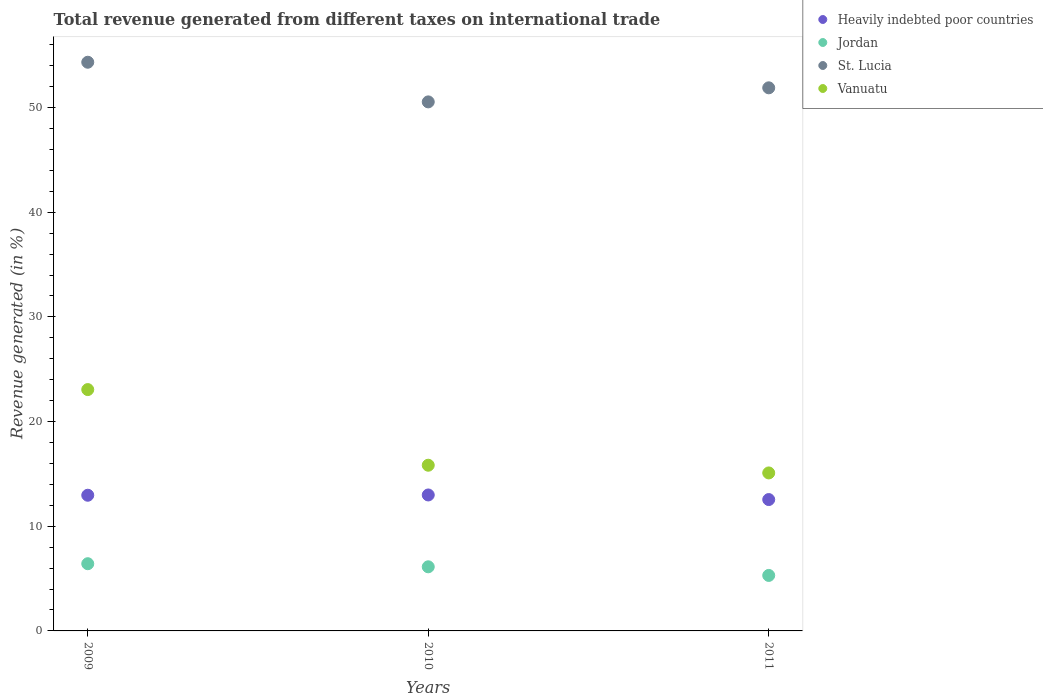Is the number of dotlines equal to the number of legend labels?
Provide a short and direct response. Yes. What is the total revenue generated in Vanuatu in 2009?
Provide a short and direct response. 23.06. Across all years, what is the maximum total revenue generated in St. Lucia?
Offer a very short reply. 54.33. Across all years, what is the minimum total revenue generated in Vanuatu?
Keep it short and to the point. 15.09. In which year was the total revenue generated in St. Lucia maximum?
Offer a terse response. 2009. In which year was the total revenue generated in Heavily indebted poor countries minimum?
Provide a short and direct response. 2011. What is the total total revenue generated in St. Lucia in the graph?
Keep it short and to the point. 156.76. What is the difference between the total revenue generated in Jordan in 2009 and that in 2011?
Your response must be concise. 1.12. What is the difference between the total revenue generated in Heavily indebted poor countries in 2011 and the total revenue generated in St. Lucia in 2010?
Keep it short and to the point. -37.99. What is the average total revenue generated in Jordan per year?
Your response must be concise. 5.95. In the year 2011, what is the difference between the total revenue generated in Heavily indebted poor countries and total revenue generated in Vanuatu?
Provide a succinct answer. -2.54. In how many years, is the total revenue generated in Heavily indebted poor countries greater than 40 %?
Provide a succinct answer. 0. What is the ratio of the total revenue generated in Jordan in 2010 to that in 2011?
Keep it short and to the point. 1.16. Is the total revenue generated in Heavily indebted poor countries in 2010 less than that in 2011?
Your answer should be compact. No. Is the difference between the total revenue generated in Heavily indebted poor countries in 2010 and 2011 greater than the difference between the total revenue generated in Vanuatu in 2010 and 2011?
Provide a succinct answer. No. What is the difference between the highest and the second highest total revenue generated in Vanuatu?
Ensure brevity in your answer.  7.23. What is the difference between the highest and the lowest total revenue generated in Jordan?
Provide a short and direct response. 1.12. Is the sum of the total revenue generated in Heavily indebted poor countries in 2010 and 2011 greater than the maximum total revenue generated in St. Lucia across all years?
Ensure brevity in your answer.  No. Does the total revenue generated in Jordan monotonically increase over the years?
Ensure brevity in your answer.  No. Is the total revenue generated in Vanuatu strictly less than the total revenue generated in St. Lucia over the years?
Provide a succinct answer. Yes. How many years are there in the graph?
Make the answer very short. 3. Are the values on the major ticks of Y-axis written in scientific E-notation?
Offer a very short reply. No. What is the title of the graph?
Give a very brief answer. Total revenue generated from different taxes on international trade. What is the label or title of the Y-axis?
Your answer should be very brief. Revenue generated (in %). What is the Revenue generated (in %) of Heavily indebted poor countries in 2009?
Make the answer very short. 12.96. What is the Revenue generated (in %) in Jordan in 2009?
Make the answer very short. 6.42. What is the Revenue generated (in %) in St. Lucia in 2009?
Keep it short and to the point. 54.33. What is the Revenue generated (in %) in Vanuatu in 2009?
Give a very brief answer. 23.06. What is the Revenue generated (in %) in Heavily indebted poor countries in 2010?
Keep it short and to the point. 12.99. What is the Revenue generated (in %) of Jordan in 2010?
Provide a short and direct response. 6.13. What is the Revenue generated (in %) in St. Lucia in 2010?
Your response must be concise. 50.54. What is the Revenue generated (in %) in Vanuatu in 2010?
Make the answer very short. 15.83. What is the Revenue generated (in %) of Heavily indebted poor countries in 2011?
Offer a terse response. 12.55. What is the Revenue generated (in %) of Jordan in 2011?
Ensure brevity in your answer.  5.3. What is the Revenue generated (in %) in St. Lucia in 2011?
Ensure brevity in your answer.  51.89. What is the Revenue generated (in %) of Vanuatu in 2011?
Your answer should be very brief. 15.09. Across all years, what is the maximum Revenue generated (in %) of Heavily indebted poor countries?
Your answer should be very brief. 12.99. Across all years, what is the maximum Revenue generated (in %) in Jordan?
Offer a terse response. 6.42. Across all years, what is the maximum Revenue generated (in %) in St. Lucia?
Ensure brevity in your answer.  54.33. Across all years, what is the maximum Revenue generated (in %) of Vanuatu?
Ensure brevity in your answer.  23.06. Across all years, what is the minimum Revenue generated (in %) in Heavily indebted poor countries?
Make the answer very short. 12.55. Across all years, what is the minimum Revenue generated (in %) in Jordan?
Give a very brief answer. 5.3. Across all years, what is the minimum Revenue generated (in %) of St. Lucia?
Offer a terse response. 50.54. Across all years, what is the minimum Revenue generated (in %) of Vanuatu?
Your response must be concise. 15.09. What is the total Revenue generated (in %) of Heavily indebted poor countries in the graph?
Your answer should be very brief. 38.5. What is the total Revenue generated (in %) in Jordan in the graph?
Keep it short and to the point. 17.85. What is the total Revenue generated (in %) of St. Lucia in the graph?
Your response must be concise. 156.76. What is the total Revenue generated (in %) of Vanuatu in the graph?
Make the answer very short. 53.98. What is the difference between the Revenue generated (in %) in Heavily indebted poor countries in 2009 and that in 2010?
Keep it short and to the point. -0.03. What is the difference between the Revenue generated (in %) in Jordan in 2009 and that in 2010?
Keep it short and to the point. 0.3. What is the difference between the Revenue generated (in %) of St. Lucia in 2009 and that in 2010?
Your answer should be very brief. 3.79. What is the difference between the Revenue generated (in %) in Vanuatu in 2009 and that in 2010?
Provide a succinct answer. 7.23. What is the difference between the Revenue generated (in %) in Heavily indebted poor countries in 2009 and that in 2011?
Keep it short and to the point. 0.41. What is the difference between the Revenue generated (in %) in Jordan in 2009 and that in 2011?
Keep it short and to the point. 1.12. What is the difference between the Revenue generated (in %) of St. Lucia in 2009 and that in 2011?
Provide a short and direct response. 2.44. What is the difference between the Revenue generated (in %) of Vanuatu in 2009 and that in 2011?
Your answer should be compact. 7.96. What is the difference between the Revenue generated (in %) in Heavily indebted poor countries in 2010 and that in 2011?
Provide a short and direct response. 0.44. What is the difference between the Revenue generated (in %) of Jordan in 2010 and that in 2011?
Your answer should be compact. 0.82. What is the difference between the Revenue generated (in %) of St. Lucia in 2010 and that in 2011?
Offer a terse response. -1.34. What is the difference between the Revenue generated (in %) of Vanuatu in 2010 and that in 2011?
Your response must be concise. 0.74. What is the difference between the Revenue generated (in %) in Heavily indebted poor countries in 2009 and the Revenue generated (in %) in Jordan in 2010?
Offer a very short reply. 6.84. What is the difference between the Revenue generated (in %) of Heavily indebted poor countries in 2009 and the Revenue generated (in %) of St. Lucia in 2010?
Make the answer very short. -37.58. What is the difference between the Revenue generated (in %) in Heavily indebted poor countries in 2009 and the Revenue generated (in %) in Vanuatu in 2010?
Your answer should be compact. -2.87. What is the difference between the Revenue generated (in %) in Jordan in 2009 and the Revenue generated (in %) in St. Lucia in 2010?
Your answer should be compact. -44.12. What is the difference between the Revenue generated (in %) of Jordan in 2009 and the Revenue generated (in %) of Vanuatu in 2010?
Offer a terse response. -9.41. What is the difference between the Revenue generated (in %) in St. Lucia in 2009 and the Revenue generated (in %) in Vanuatu in 2010?
Provide a succinct answer. 38.5. What is the difference between the Revenue generated (in %) of Heavily indebted poor countries in 2009 and the Revenue generated (in %) of Jordan in 2011?
Provide a succinct answer. 7.66. What is the difference between the Revenue generated (in %) in Heavily indebted poor countries in 2009 and the Revenue generated (in %) in St. Lucia in 2011?
Your answer should be compact. -38.92. What is the difference between the Revenue generated (in %) in Heavily indebted poor countries in 2009 and the Revenue generated (in %) in Vanuatu in 2011?
Your response must be concise. -2.13. What is the difference between the Revenue generated (in %) of Jordan in 2009 and the Revenue generated (in %) of St. Lucia in 2011?
Your response must be concise. -45.46. What is the difference between the Revenue generated (in %) in Jordan in 2009 and the Revenue generated (in %) in Vanuatu in 2011?
Your answer should be compact. -8.67. What is the difference between the Revenue generated (in %) of St. Lucia in 2009 and the Revenue generated (in %) of Vanuatu in 2011?
Ensure brevity in your answer.  39.24. What is the difference between the Revenue generated (in %) of Heavily indebted poor countries in 2010 and the Revenue generated (in %) of Jordan in 2011?
Your answer should be very brief. 7.69. What is the difference between the Revenue generated (in %) in Heavily indebted poor countries in 2010 and the Revenue generated (in %) in St. Lucia in 2011?
Offer a very short reply. -38.9. What is the difference between the Revenue generated (in %) of Heavily indebted poor countries in 2010 and the Revenue generated (in %) of Vanuatu in 2011?
Your response must be concise. -2.11. What is the difference between the Revenue generated (in %) in Jordan in 2010 and the Revenue generated (in %) in St. Lucia in 2011?
Your answer should be very brief. -45.76. What is the difference between the Revenue generated (in %) in Jordan in 2010 and the Revenue generated (in %) in Vanuatu in 2011?
Keep it short and to the point. -8.97. What is the difference between the Revenue generated (in %) of St. Lucia in 2010 and the Revenue generated (in %) of Vanuatu in 2011?
Your response must be concise. 35.45. What is the average Revenue generated (in %) in Heavily indebted poor countries per year?
Your answer should be very brief. 12.83. What is the average Revenue generated (in %) in Jordan per year?
Your answer should be compact. 5.95. What is the average Revenue generated (in %) of St. Lucia per year?
Your answer should be compact. 52.25. What is the average Revenue generated (in %) of Vanuatu per year?
Your answer should be very brief. 17.99. In the year 2009, what is the difference between the Revenue generated (in %) in Heavily indebted poor countries and Revenue generated (in %) in Jordan?
Provide a short and direct response. 6.54. In the year 2009, what is the difference between the Revenue generated (in %) of Heavily indebted poor countries and Revenue generated (in %) of St. Lucia?
Make the answer very short. -41.37. In the year 2009, what is the difference between the Revenue generated (in %) of Heavily indebted poor countries and Revenue generated (in %) of Vanuatu?
Offer a very short reply. -10.09. In the year 2009, what is the difference between the Revenue generated (in %) of Jordan and Revenue generated (in %) of St. Lucia?
Make the answer very short. -47.91. In the year 2009, what is the difference between the Revenue generated (in %) of Jordan and Revenue generated (in %) of Vanuatu?
Give a very brief answer. -16.64. In the year 2009, what is the difference between the Revenue generated (in %) in St. Lucia and Revenue generated (in %) in Vanuatu?
Your answer should be compact. 31.27. In the year 2010, what is the difference between the Revenue generated (in %) in Heavily indebted poor countries and Revenue generated (in %) in Jordan?
Offer a terse response. 6.86. In the year 2010, what is the difference between the Revenue generated (in %) of Heavily indebted poor countries and Revenue generated (in %) of St. Lucia?
Give a very brief answer. -37.55. In the year 2010, what is the difference between the Revenue generated (in %) of Heavily indebted poor countries and Revenue generated (in %) of Vanuatu?
Your answer should be compact. -2.84. In the year 2010, what is the difference between the Revenue generated (in %) of Jordan and Revenue generated (in %) of St. Lucia?
Your response must be concise. -44.42. In the year 2010, what is the difference between the Revenue generated (in %) of Jordan and Revenue generated (in %) of Vanuatu?
Your answer should be compact. -9.7. In the year 2010, what is the difference between the Revenue generated (in %) of St. Lucia and Revenue generated (in %) of Vanuatu?
Ensure brevity in your answer.  34.71. In the year 2011, what is the difference between the Revenue generated (in %) in Heavily indebted poor countries and Revenue generated (in %) in Jordan?
Give a very brief answer. 7.25. In the year 2011, what is the difference between the Revenue generated (in %) of Heavily indebted poor countries and Revenue generated (in %) of St. Lucia?
Make the answer very short. -39.34. In the year 2011, what is the difference between the Revenue generated (in %) of Heavily indebted poor countries and Revenue generated (in %) of Vanuatu?
Ensure brevity in your answer.  -2.54. In the year 2011, what is the difference between the Revenue generated (in %) of Jordan and Revenue generated (in %) of St. Lucia?
Provide a succinct answer. -46.58. In the year 2011, what is the difference between the Revenue generated (in %) of Jordan and Revenue generated (in %) of Vanuatu?
Offer a very short reply. -9.79. In the year 2011, what is the difference between the Revenue generated (in %) of St. Lucia and Revenue generated (in %) of Vanuatu?
Offer a very short reply. 36.79. What is the ratio of the Revenue generated (in %) of Heavily indebted poor countries in 2009 to that in 2010?
Offer a very short reply. 1. What is the ratio of the Revenue generated (in %) of Jordan in 2009 to that in 2010?
Provide a short and direct response. 1.05. What is the ratio of the Revenue generated (in %) of St. Lucia in 2009 to that in 2010?
Your response must be concise. 1.07. What is the ratio of the Revenue generated (in %) of Vanuatu in 2009 to that in 2010?
Offer a terse response. 1.46. What is the ratio of the Revenue generated (in %) of Heavily indebted poor countries in 2009 to that in 2011?
Make the answer very short. 1.03. What is the ratio of the Revenue generated (in %) of Jordan in 2009 to that in 2011?
Offer a very short reply. 1.21. What is the ratio of the Revenue generated (in %) of St. Lucia in 2009 to that in 2011?
Make the answer very short. 1.05. What is the ratio of the Revenue generated (in %) in Vanuatu in 2009 to that in 2011?
Make the answer very short. 1.53. What is the ratio of the Revenue generated (in %) in Heavily indebted poor countries in 2010 to that in 2011?
Make the answer very short. 1.03. What is the ratio of the Revenue generated (in %) in Jordan in 2010 to that in 2011?
Your answer should be very brief. 1.16. What is the ratio of the Revenue generated (in %) in St. Lucia in 2010 to that in 2011?
Keep it short and to the point. 0.97. What is the ratio of the Revenue generated (in %) of Vanuatu in 2010 to that in 2011?
Your answer should be compact. 1.05. What is the difference between the highest and the second highest Revenue generated (in %) of Heavily indebted poor countries?
Offer a very short reply. 0.03. What is the difference between the highest and the second highest Revenue generated (in %) of Jordan?
Give a very brief answer. 0.3. What is the difference between the highest and the second highest Revenue generated (in %) of St. Lucia?
Offer a very short reply. 2.44. What is the difference between the highest and the second highest Revenue generated (in %) of Vanuatu?
Provide a short and direct response. 7.23. What is the difference between the highest and the lowest Revenue generated (in %) of Heavily indebted poor countries?
Give a very brief answer. 0.44. What is the difference between the highest and the lowest Revenue generated (in %) in Jordan?
Provide a short and direct response. 1.12. What is the difference between the highest and the lowest Revenue generated (in %) of St. Lucia?
Provide a succinct answer. 3.79. What is the difference between the highest and the lowest Revenue generated (in %) in Vanuatu?
Offer a very short reply. 7.96. 